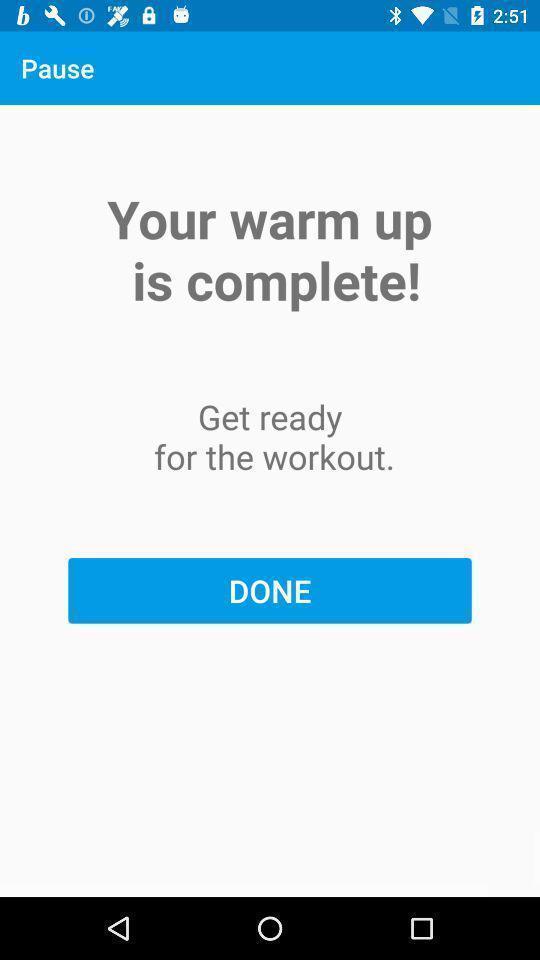What is the overall content of this screenshot? Page that displaying workout application. 